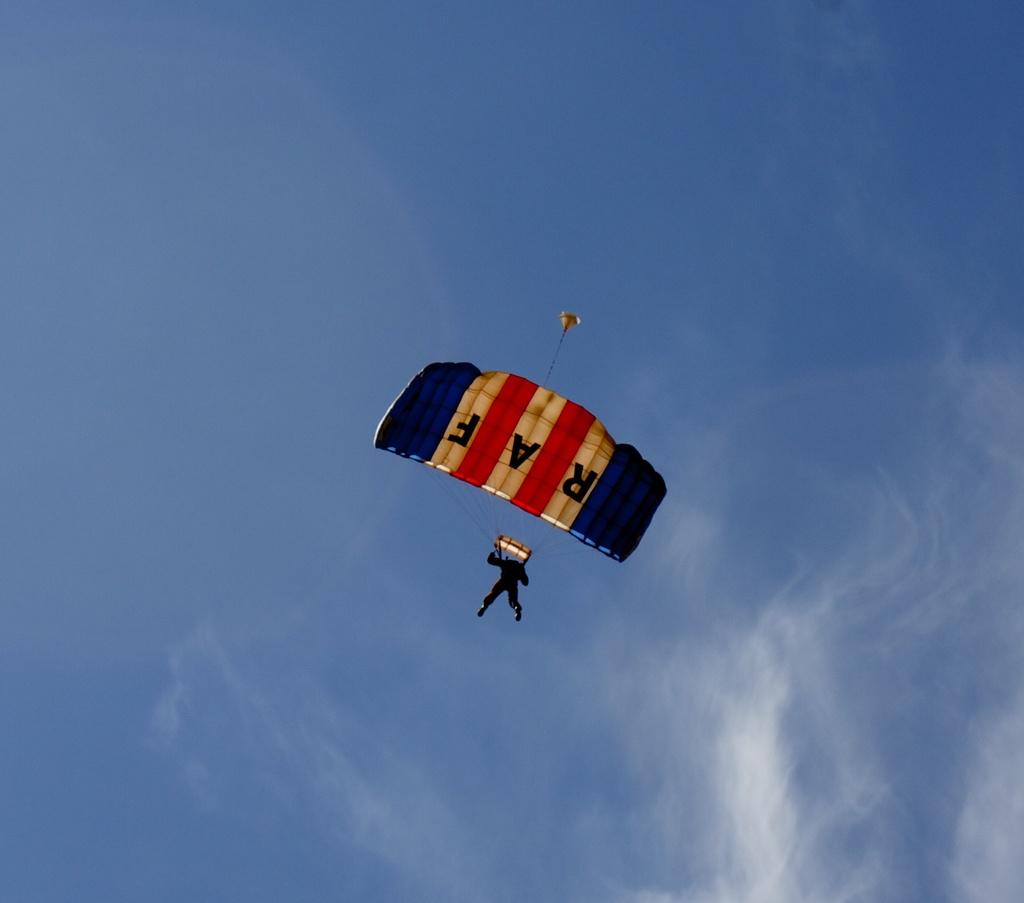What letters are embellished on the parachute?
Offer a terse response. Raf. What are the letters being displayed?
Make the answer very short. Raf. 